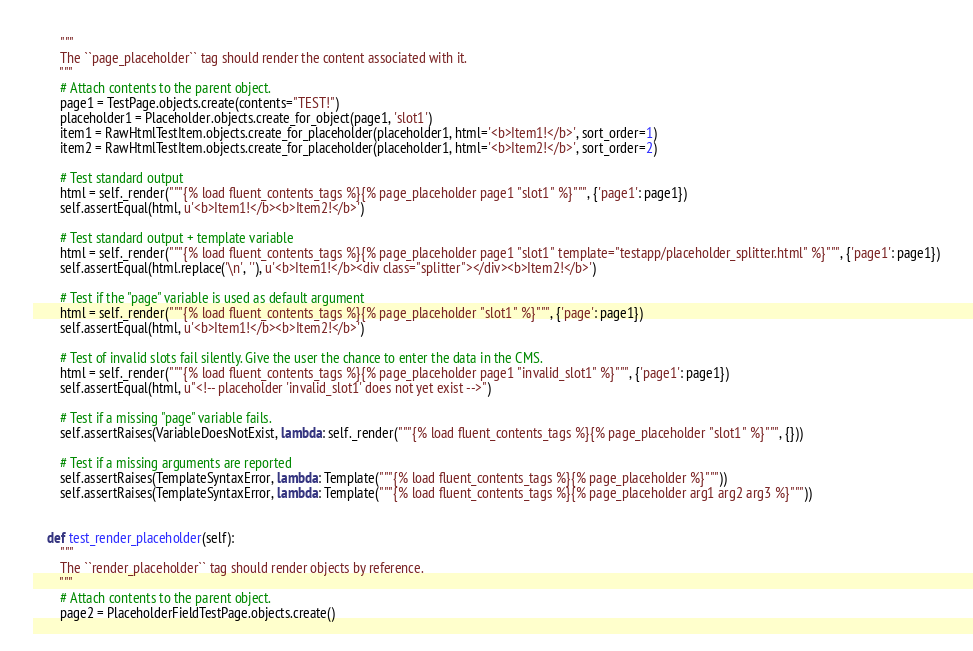Convert code to text. <code><loc_0><loc_0><loc_500><loc_500><_Python_>        """
        The ``page_placeholder`` tag should render the content associated with it.
        """
        # Attach contents to the parent object.
        page1 = TestPage.objects.create(contents="TEST!")
        placeholder1 = Placeholder.objects.create_for_object(page1, 'slot1')
        item1 = RawHtmlTestItem.objects.create_for_placeholder(placeholder1, html='<b>Item1!</b>', sort_order=1)
        item2 = RawHtmlTestItem.objects.create_for_placeholder(placeholder1, html='<b>Item2!</b>', sort_order=2)

        # Test standard output
        html = self._render("""{% load fluent_contents_tags %}{% page_placeholder page1 "slot1" %}""", {'page1': page1})
        self.assertEqual(html, u'<b>Item1!</b><b>Item2!</b>')

        # Test standard output + template variable
        html = self._render("""{% load fluent_contents_tags %}{% page_placeholder page1 "slot1" template="testapp/placeholder_splitter.html" %}""", {'page1': page1})
        self.assertEqual(html.replace('\n', ''), u'<b>Item1!</b><div class="splitter"></div><b>Item2!</b>')

        # Test if the "page" variable is used as default argument
        html = self._render("""{% load fluent_contents_tags %}{% page_placeholder "slot1" %}""", {'page': page1})
        self.assertEqual(html, u'<b>Item1!</b><b>Item2!</b>')

        # Test of invalid slots fail silently. Give the user the chance to enter the data in the CMS.
        html = self._render("""{% load fluent_contents_tags %}{% page_placeholder page1 "invalid_slot1" %}""", {'page1': page1})
        self.assertEqual(html, u"<!-- placeholder 'invalid_slot1' does not yet exist -->")

        # Test if a missing "page" variable fails.
        self.assertRaises(VariableDoesNotExist, lambda: self._render("""{% load fluent_contents_tags %}{% page_placeholder "slot1" %}""", {}))

        # Test if a missing arguments are reported
        self.assertRaises(TemplateSyntaxError, lambda: Template("""{% load fluent_contents_tags %}{% page_placeholder %}"""))
        self.assertRaises(TemplateSyntaxError, lambda: Template("""{% load fluent_contents_tags %}{% page_placeholder arg1 arg2 arg3 %}"""))


    def test_render_placeholder(self):
        """
        The ``render_placeholder`` tag should render objects by reference.
        """
        # Attach contents to the parent object.
        page2 = PlaceholderFieldTestPage.objects.create()</code> 